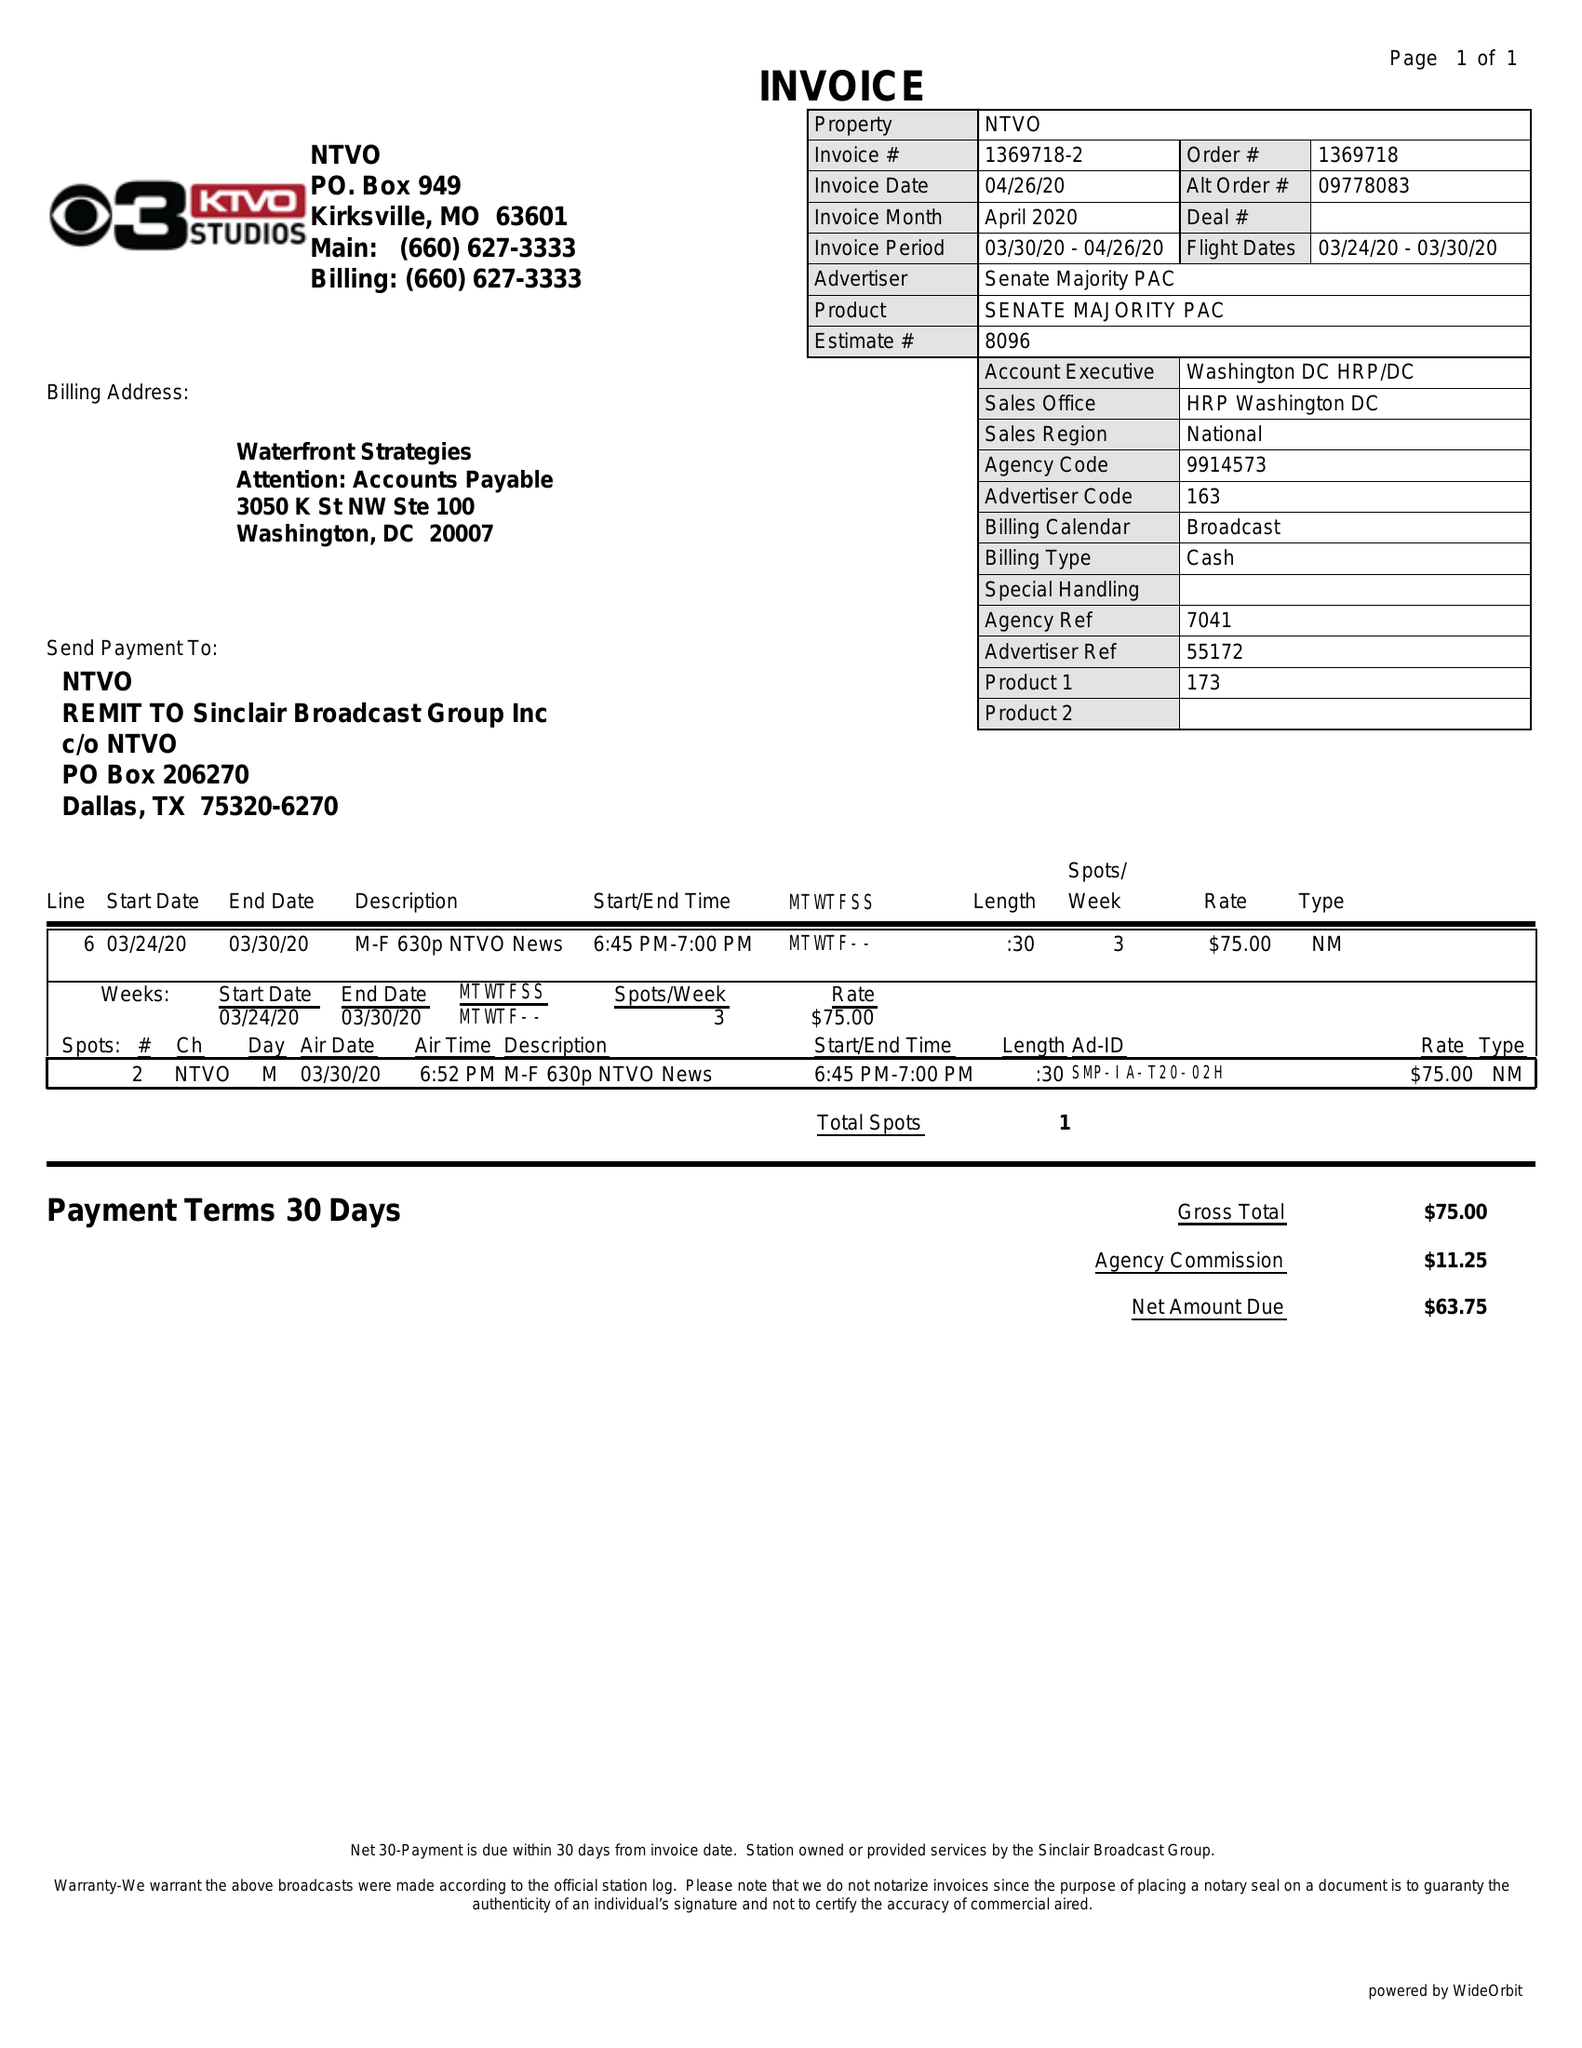What is the value for the gross_amount?
Answer the question using a single word or phrase. 75.00 